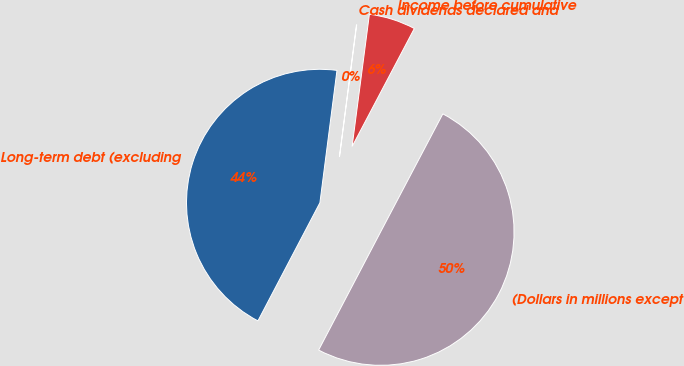Convert chart to OTSL. <chart><loc_0><loc_0><loc_500><loc_500><pie_chart><fcel>(Dollars in millions except<fcel>Income before cumulative<fcel>Cash dividends declared and<fcel>Long-term debt (excluding<nl><fcel>49.97%<fcel>5.65%<fcel>0.03%<fcel>44.35%<nl></chart> 